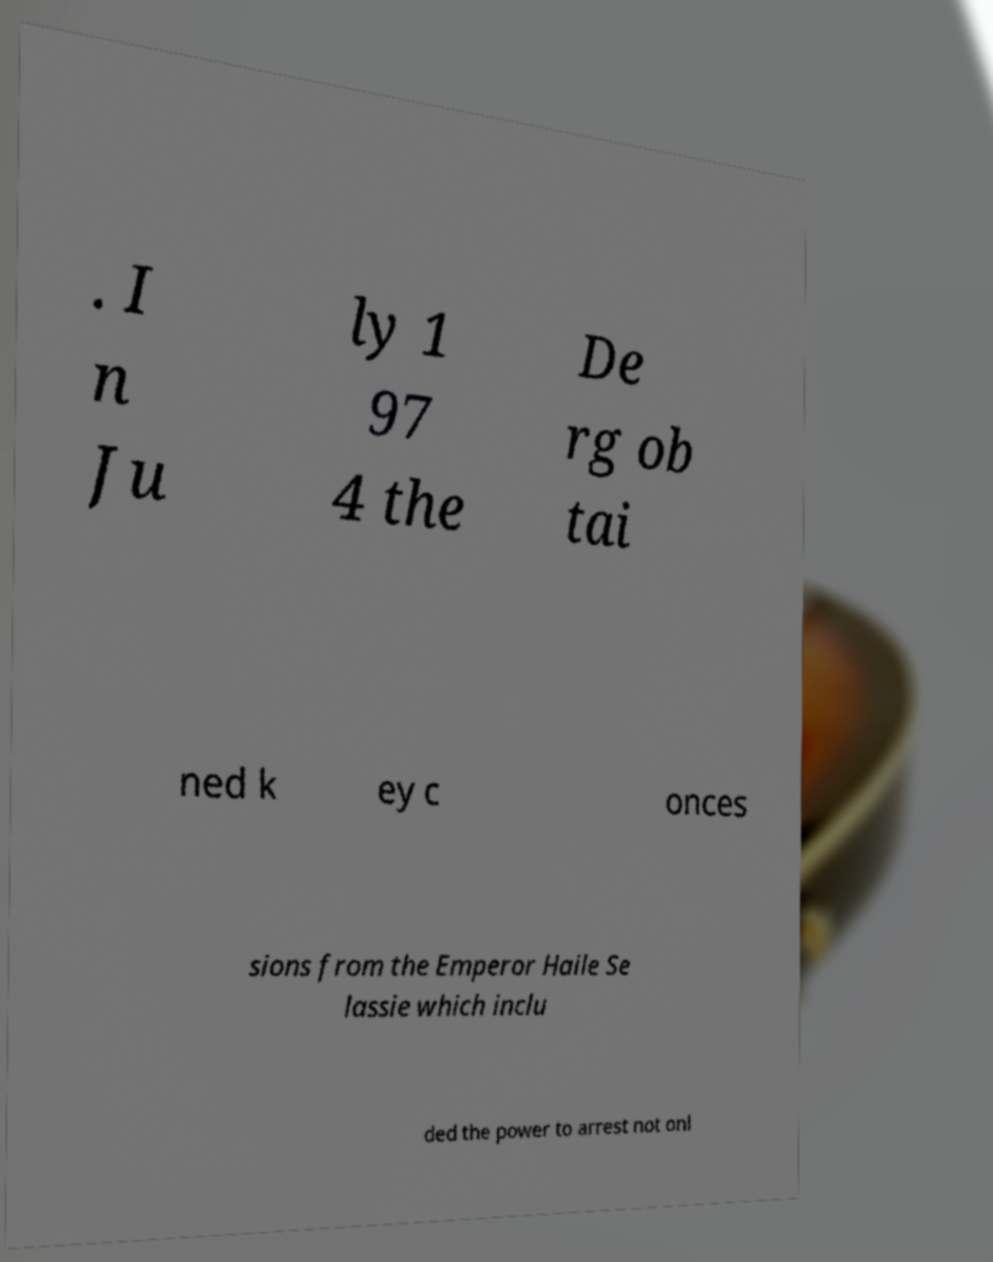Could you assist in decoding the text presented in this image and type it out clearly? . I n Ju ly 1 97 4 the De rg ob tai ned k ey c onces sions from the Emperor Haile Se lassie which inclu ded the power to arrest not onl 